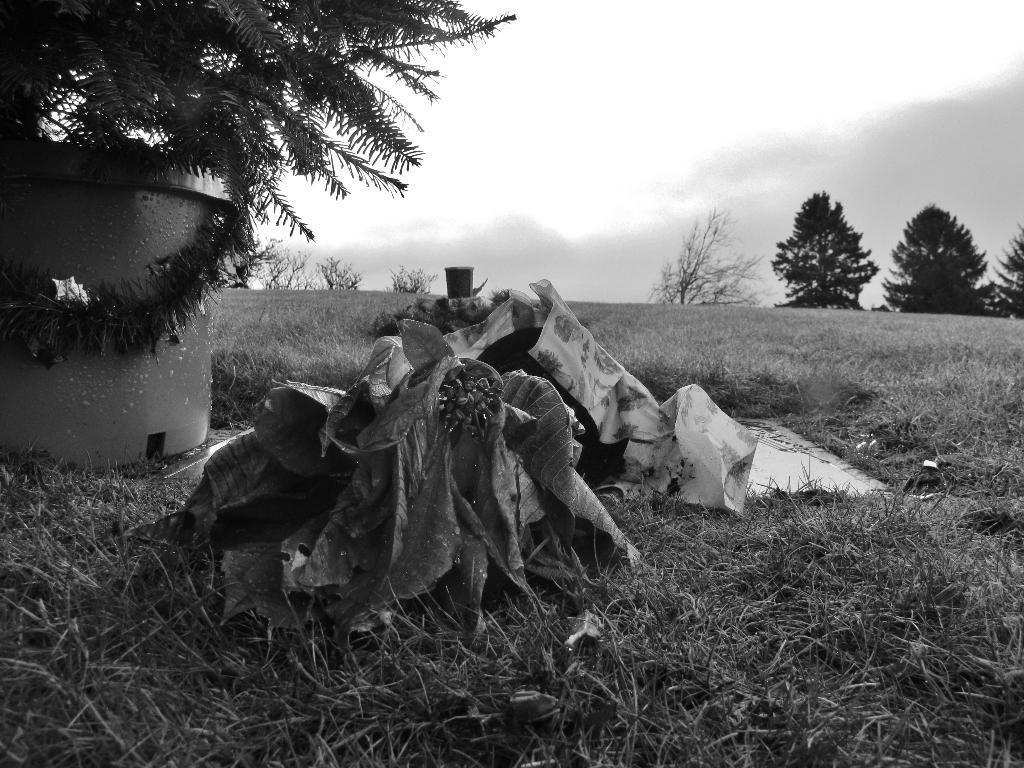How would you summarize this image in a sentence or two? This picture show that some garbage and plastic cover is placed on the grass lawn. Beside we can see a tree and round concrete tank. In the background we can see some trees. 